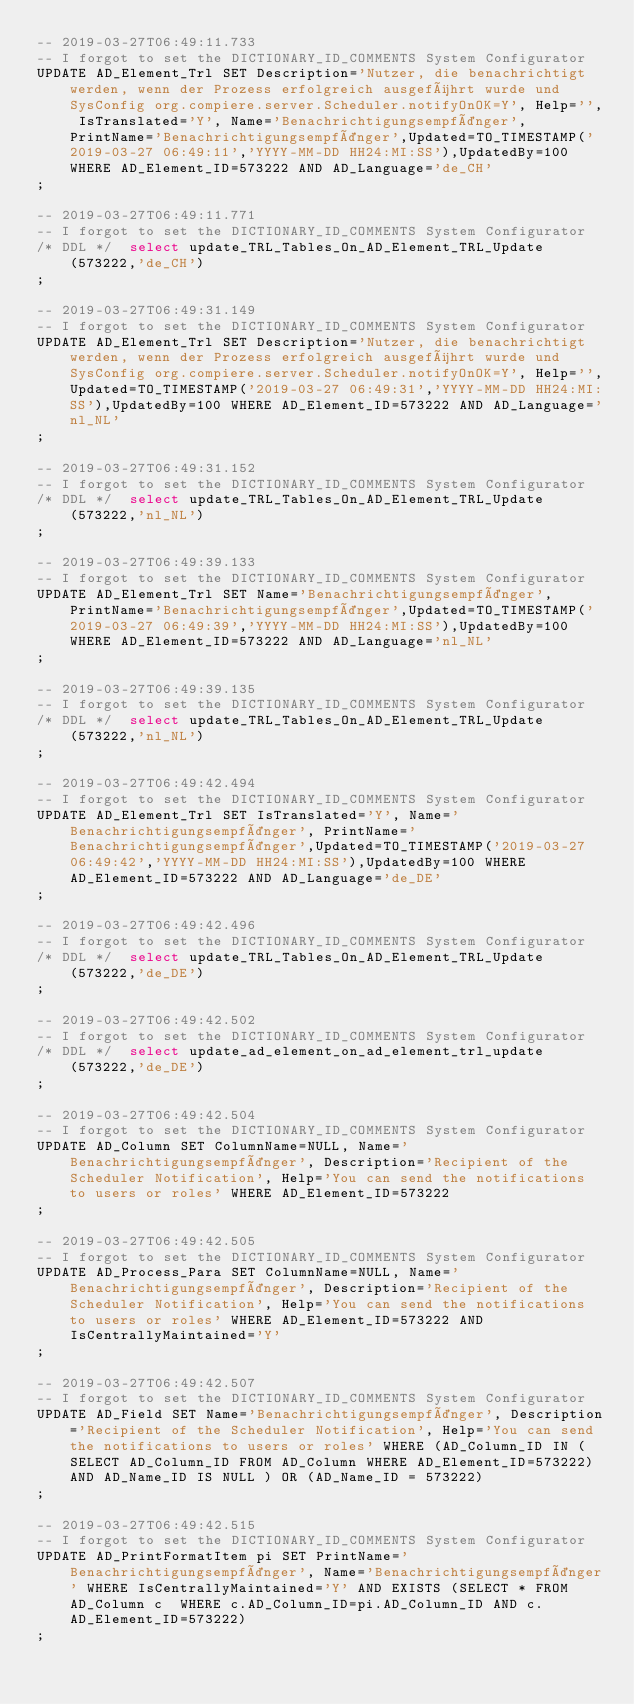<code> <loc_0><loc_0><loc_500><loc_500><_SQL_>-- 2019-03-27T06:49:11.733
-- I forgot to set the DICTIONARY_ID_COMMENTS System Configurator
UPDATE AD_Element_Trl SET Description='Nutzer, die benachrichtigt werden, wenn der Prozess erfolgreich ausgeführt wurde und SysConfig org.compiere.server.Scheduler.notifyOnOK=Y', Help='', IsTranslated='Y', Name='Benachrichtigungsempfänger', PrintName='Benachrichtigungsempfänger',Updated=TO_TIMESTAMP('2019-03-27 06:49:11','YYYY-MM-DD HH24:MI:SS'),UpdatedBy=100 WHERE AD_Element_ID=573222 AND AD_Language='de_CH'
;

-- 2019-03-27T06:49:11.771
-- I forgot to set the DICTIONARY_ID_COMMENTS System Configurator
/* DDL */  select update_TRL_Tables_On_AD_Element_TRL_Update(573222,'de_CH') 
;

-- 2019-03-27T06:49:31.149
-- I forgot to set the DICTIONARY_ID_COMMENTS System Configurator
UPDATE AD_Element_Trl SET Description='Nutzer, die benachrichtigt werden, wenn der Prozess erfolgreich ausgeführt wurde und SysConfig org.compiere.server.Scheduler.notifyOnOK=Y', Help='',Updated=TO_TIMESTAMP('2019-03-27 06:49:31','YYYY-MM-DD HH24:MI:SS'),UpdatedBy=100 WHERE AD_Element_ID=573222 AND AD_Language='nl_NL'
;

-- 2019-03-27T06:49:31.152
-- I forgot to set the DICTIONARY_ID_COMMENTS System Configurator
/* DDL */  select update_TRL_Tables_On_AD_Element_TRL_Update(573222,'nl_NL') 
;

-- 2019-03-27T06:49:39.133
-- I forgot to set the DICTIONARY_ID_COMMENTS System Configurator
UPDATE AD_Element_Trl SET Name='Benachrichtigungsempfänger', PrintName='Benachrichtigungsempfänger',Updated=TO_TIMESTAMP('2019-03-27 06:49:39','YYYY-MM-DD HH24:MI:SS'),UpdatedBy=100 WHERE AD_Element_ID=573222 AND AD_Language='nl_NL'
;

-- 2019-03-27T06:49:39.135
-- I forgot to set the DICTIONARY_ID_COMMENTS System Configurator
/* DDL */  select update_TRL_Tables_On_AD_Element_TRL_Update(573222,'nl_NL') 
;

-- 2019-03-27T06:49:42.494
-- I forgot to set the DICTIONARY_ID_COMMENTS System Configurator
UPDATE AD_Element_Trl SET IsTranslated='Y', Name='Benachrichtigungsempfänger', PrintName='Benachrichtigungsempfänger',Updated=TO_TIMESTAMP('2019-03-27 06:49:42','YYYY-MM-DD HH24:MI:SS'),UpdatedBy=100 WHERE AD_Element_ID=573222 AND AD_Language='de_DE'
;

-- 2019-03-27T06:49:42.496
-- I forgot to set the DICTIONARY_ID_COMMENTS System Configurator
/* DDL */  select update_TRL_Tables_On_AD_Element_TRL_Update(573222,'de_DE') 
;

-- 2019-03-27T06:49:42.502
-- I forgot to set the DICTIONARY_ID_COMMENTS System Configurator
/* DDL */  select update_ad_element_on_ad_element_trl_update(573222,'de_DE') 
;

-- 2019-03-27T06:49:42.504
-- I forgot to set the DICTIONARY_ID_COMMENTS System Configurator
UPDATE AD_Column SET ColumnName=NULL, Name='Benachrichtigungsempfänger', Description='Recipient of the Scheduler Notification', Help='You can send the notifications to users or roles' WHERE AD_Element_ID=573222
;

-- 2019-03-27T06:49:42.505
-- I forgot to set the DICTIONARY_ID_COMMENTS System Configurator
UPDATE AD_Process_Para SET ColumnName=NULL, Name='Benachrichtigungsempfänger', Description='Recipient of the Scheduler Notification', Help='You can send the notifications to users or roles' WHERE AD_Element_ID=573222 AND IsCentrallyMaintained='Y'
;

-- 2019-03-27T06:49:42.507
-- I forgot to set the DICTIONARY_ID_COMMENTS System Configurator
UPDATE AD_Field SET Name='Benachrichtigungsempfänger', Description='Recipient of the Scheduler Notification', Help='You can send the notifications to users or roles' WHERE (AD_Column_ID IN (SELECT AD_Column_ID FROM AD_Column WHERE AD_Element_ID=573222) AND AD_Name_ID IS NULL ) OR (AD_Name_ID = 573222)
;

-- 2019-03-27T06:49:42.515
-- I forgot to set the DICTIONARY_ID_COMMENTS System Configurator
UPDATE AD_PrintFormatItem pi SET PrintName='Benachrichtigungsempfänger', Name='Benachrichtigungsempfänger' WHERE IsCentrallyMaintained='Y' AND EXISTS (SELECT * FROM AD_Column c  WHERE c.AD_Column_ID=pi.AD_Column_ID AND c.AD_Element_ID=573222)
;
</code> 